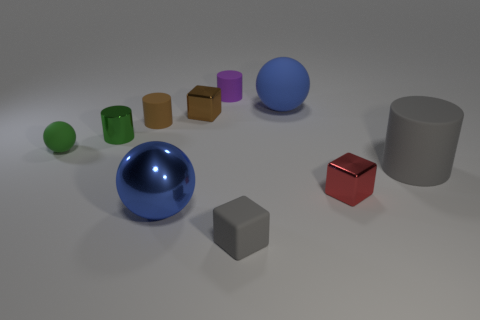How many objects are tiny blocks to the left of the tiny purple rubber cylinder or shiny things?
Ensure brevity in your answer.  4. What number of other objects are the same size as the purple rubber object?
Your answer should be very brief. 6. There is a blue sphere in front of the red block; what is its size?
Keep it short and to the point. Large. What is the shape of the blue thing that is made of the same material as the red object?
Your answer should be compact. Sphere. Is there any other thing of the same color as the large matte sphere?
Give a very brief answer. Yes. What is the color of the block behind the rubber sphere that is on the left side of the tiny brown matte object?
Your response must be concise. Brown. How many big things are either purple metal cylinders or brown metal objects?
Offer a terse response. 0. There is a small green object that is the same shape as the purple thing; what is it made of?
Offer a very short reply. Metal. What is the color of the large cylinder?
Ensure brevity in your answer.  Gray. Is the metal sphere the same color as the big matte ball?
Give a very brief answer. Yes. 